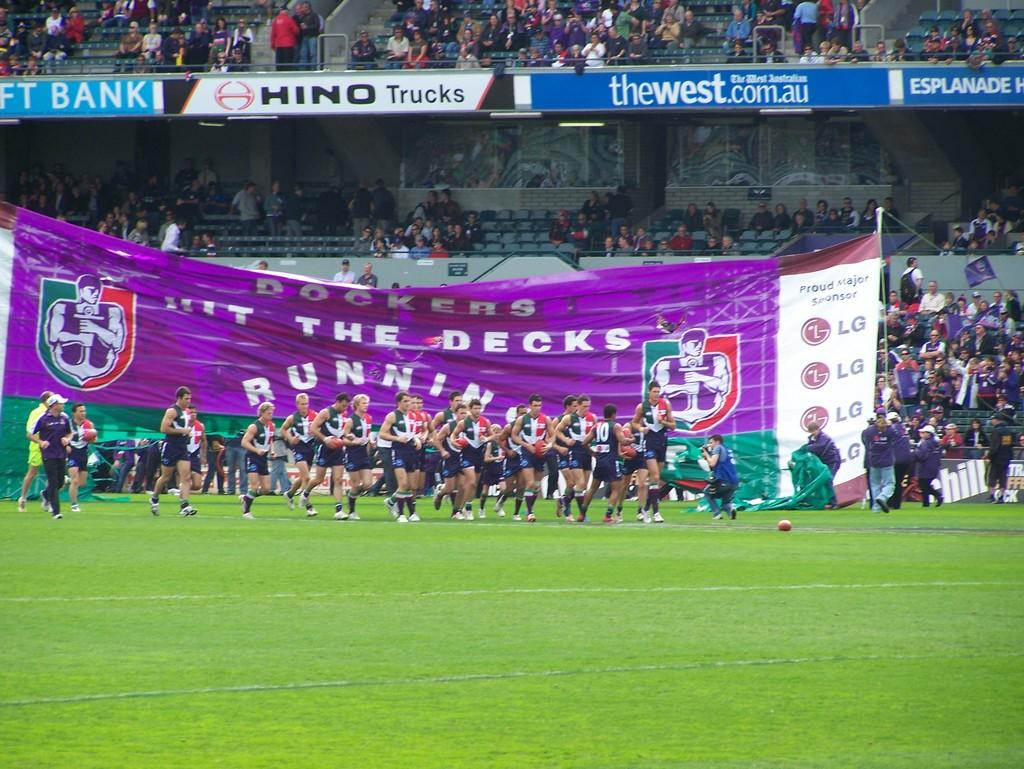<image>
Present a compact description of the photo's key features. Soccer stadium showing a purple banner that says "The Decks" on it. 